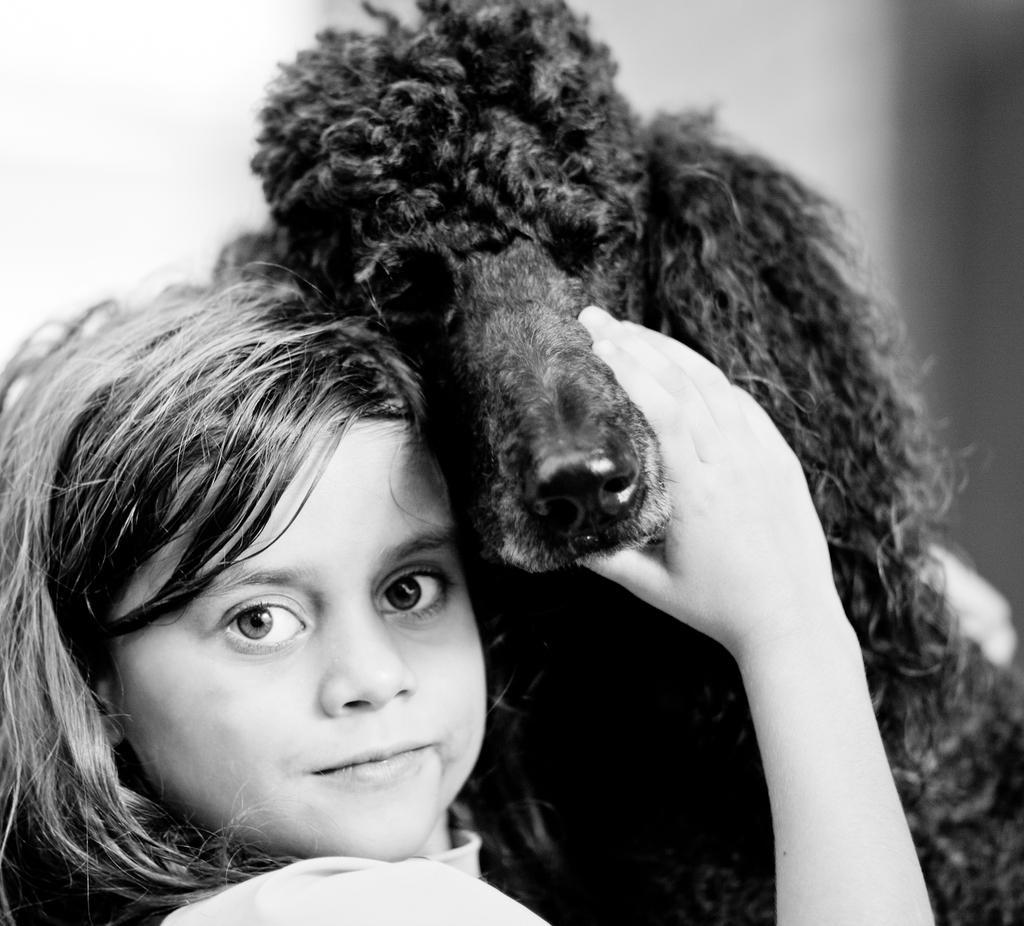In one or two sentences, can you explain what this image depicts? This is a black and white image. Here is a girl smiling. She is holding a dog. 